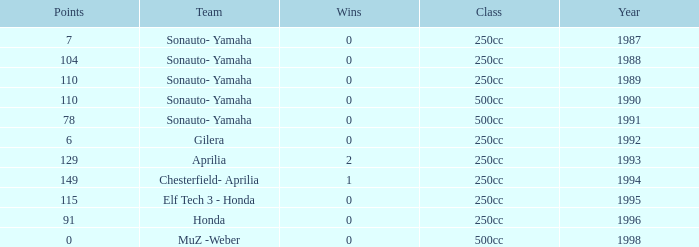How many wins did the team, which had more than 110 points, have in 1989? None. 